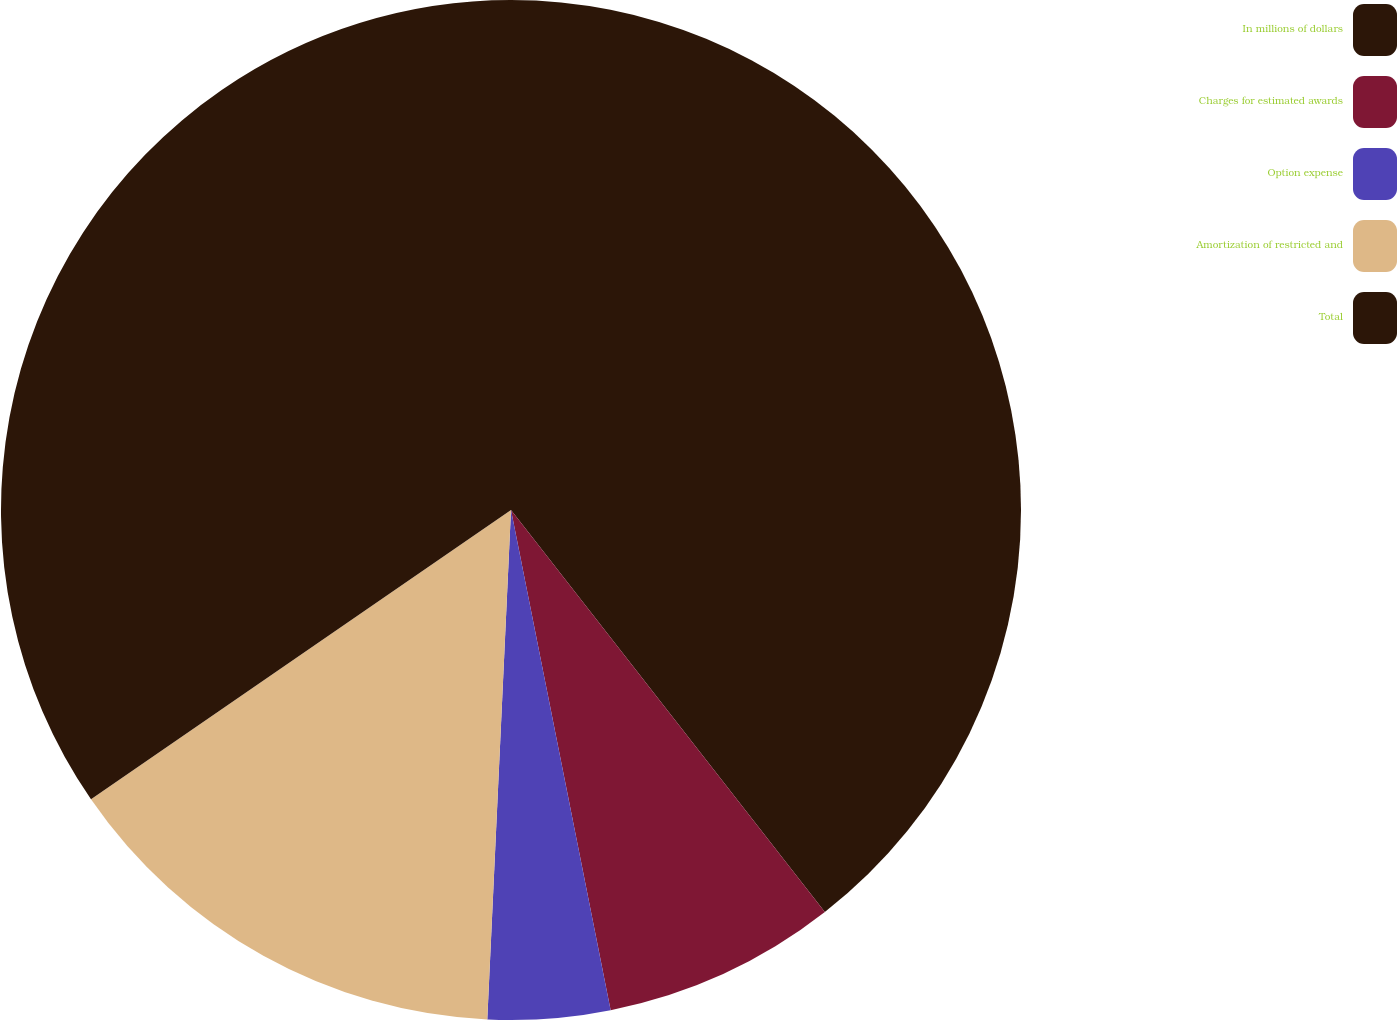Convert chart. <chart><loc_0><loc_0><loc_500><loc_500><pie_chart><fcel>In millions of dollars<fcel>Charges for estimated awards<fcel>Option expense<fcel>Amortization of restricted and<fcel>Total<nl><fcel>39.45%<fcel>7.42%<fcel>3.87%<fcel>14.66%<fcel>34.6%<nl></chart> 